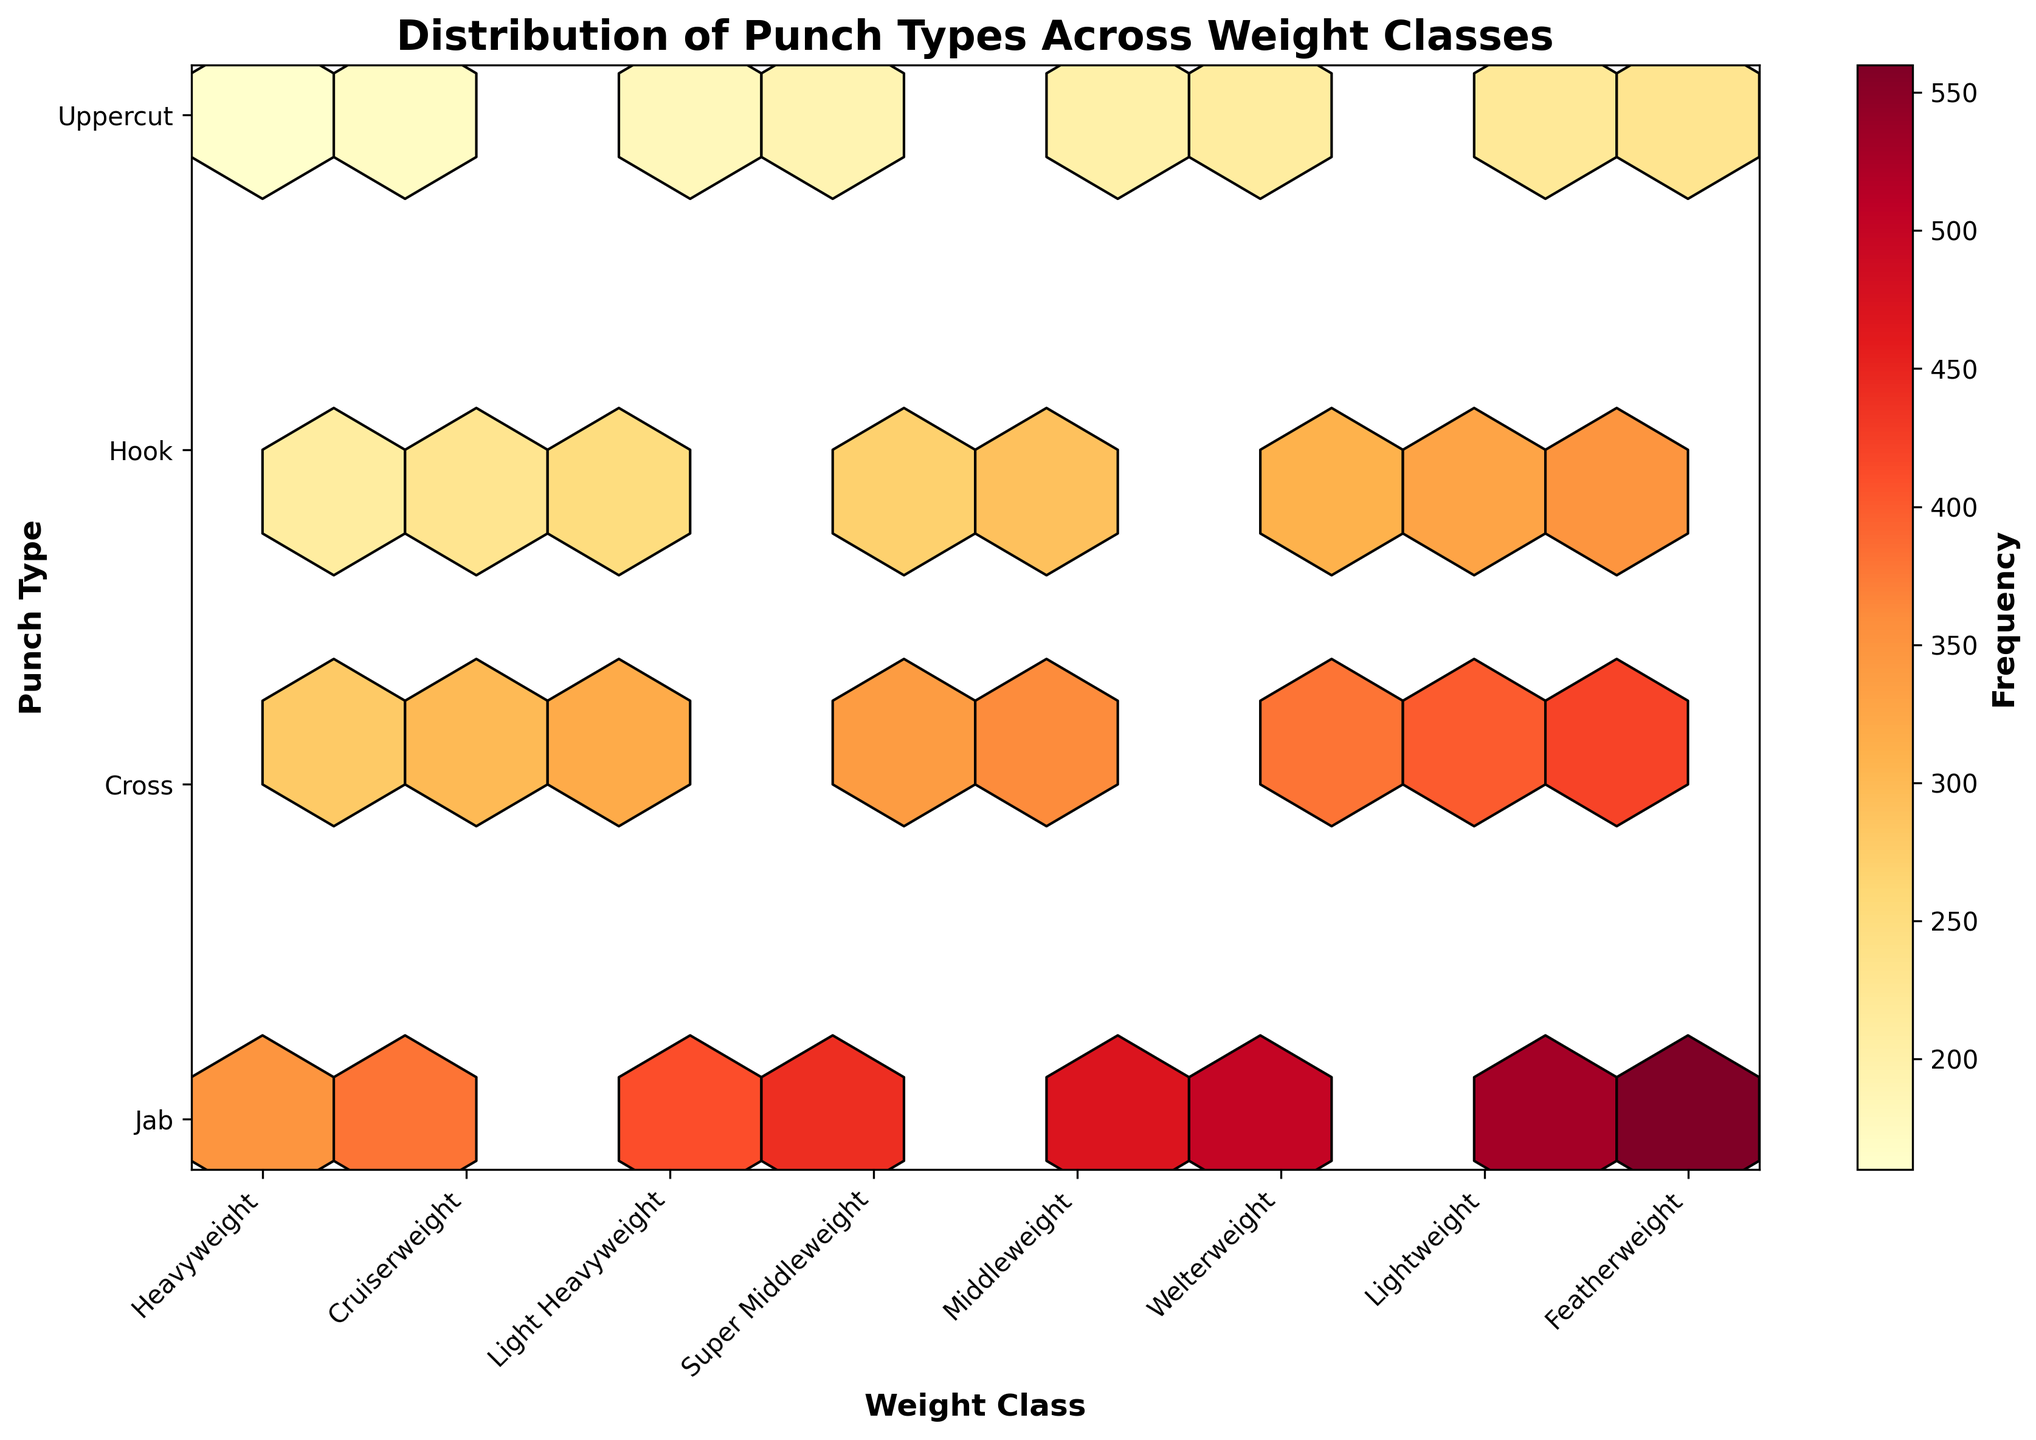What is the title of the plot? The title is usually located at the top of the plot and can be read directly.
Answer: Distribution of Punch Types Across Weight Classes What is the most frequently thrown punch type among all weight classes? Review the hexbin plot to identify the brightest color in the hexagons, indicating the highest frequency. Then, cross-reference the y-axis label that aligns with that hexagon.
Answer: Jab Which weight class has the highest frequency for Uppercuts? Identify the hexagon associated with Uppercuts and locate the brightest hexagon on the x-axis to find the highest frequency. Then, refer to the weight class label on the x-axis.
Answer: Featherweight How many different weight classes are represented in the plot? Count the number of unique labels on the x-axis to determine the number of weight classes.
Answer: 8 Which punch type has the smallest variation in frequency across all weight classes? Compare the range of colors for each punch type across the weight classes. The punch type with the least variation in shade is the one with the smallest variation in frequency.
Answer: Uppercut For the Welterweight class, sum the frequencies of all types of punches thrown. What is the total? Locate the frequencies for all punches within the Welterweight weight class (Jab, Cross, Hook, Uppercut) and sum them up: 500 + 380 + 310 + 210.
Answer: 1400 Compare the frequency of Jabs between Lightweight and Heavyweight. Which weight class has more Jabs thrown, and by how much? Find the hexagons for Jabs in Lightweight and Heavyweight, refer to their respective heights on the y-axis, and determine the difference: 530 - 350.
Answer: Lightweight, by 180 What is the average frequency of Hooks across all weight classes? Sum the frequencies of Hooks for all weight classes and divide by the number of weight classes: (210 + 230 + 250 + 270 + 290 + 310 + 330 + 350) / 8.
Answer: 280 Which punch type in the Featherweight weight class has the least frequency of throws? Locate the hexagons corresponding to the Featherweight weight class and identify which punch type has the darkest shade indicating the lowest frequency.
Answer: Uppercut How does the frequency distribution of Crosses compare between Lightweight and Middleweight? Observe the hexagons for Crosses in both Lightweight and Middleweight, and compare their colors to see which has a higher or lower frequency.
Answer: Lightweight has a higher frequency than Middleweight 